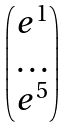<formula> <loc_0><loc_0><loc_500><loc_500>\begin{pmatrix} e ^ { 1 } \\ \dots \\ e ^ { 5 } \end{pmatrix}</formula> 